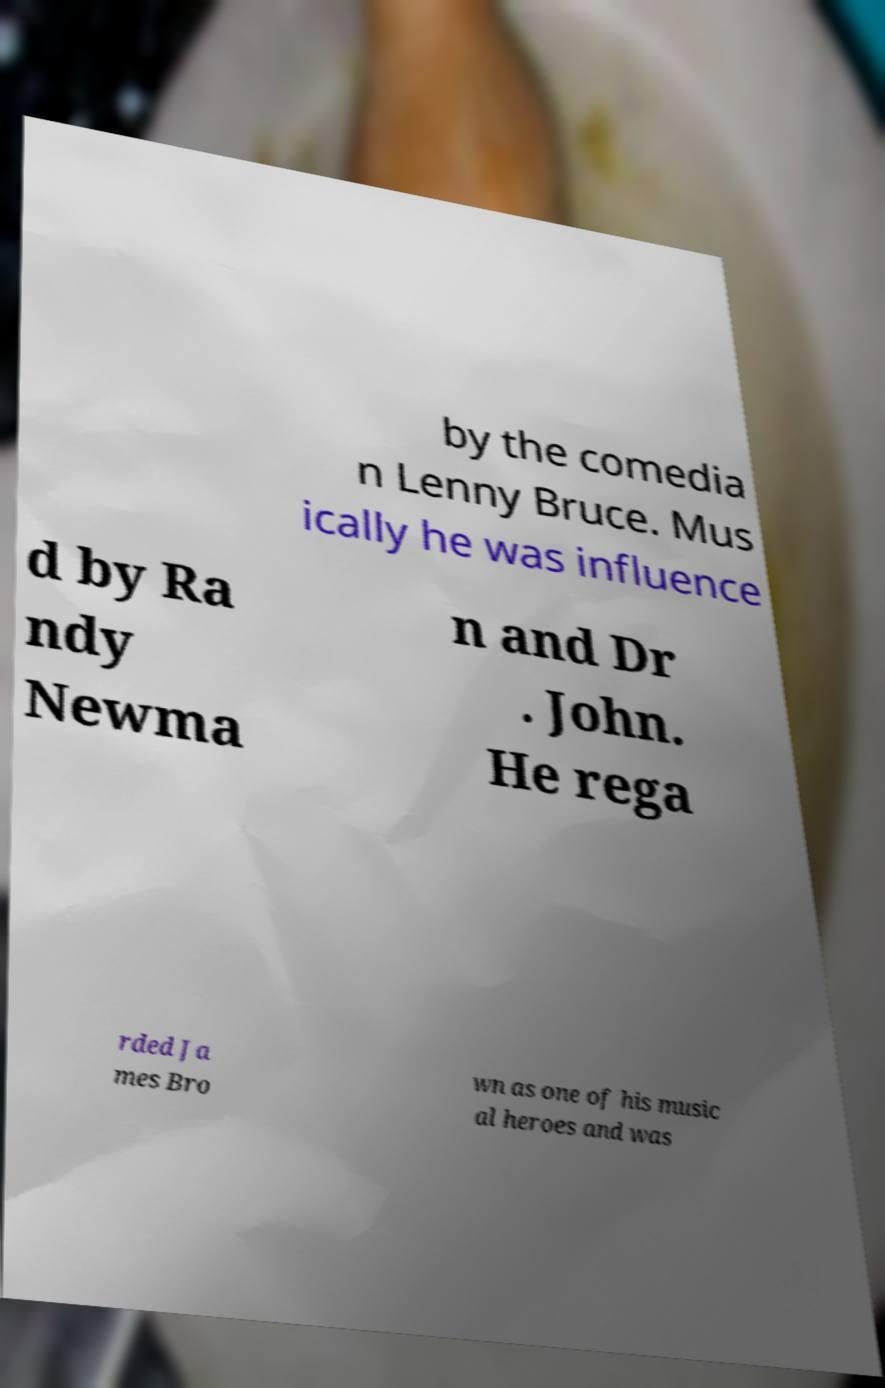What messages or text are displayed in this image? I need them in a readable, typed format. by the comedia n Lenny Bruce. Mus ically he was influence d by Ra ndy Newma n and Dr . John. He rega rded Ja mes Bro wn as one of his music al heroes and was 